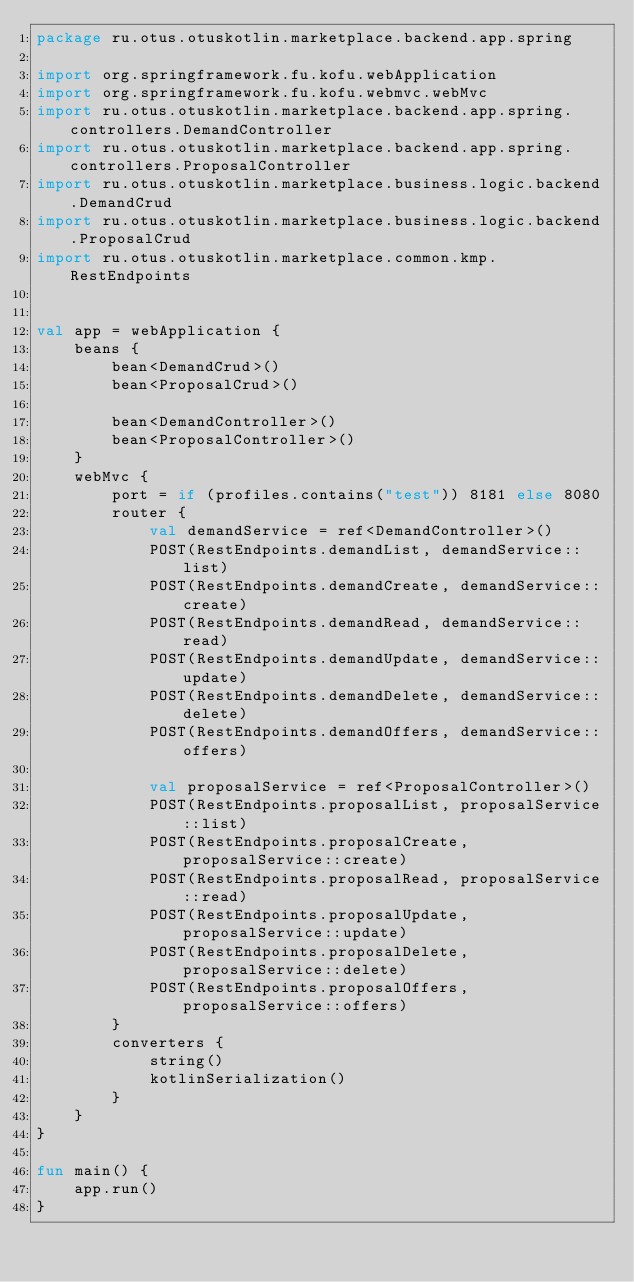<code> <loc_0><loc_0><loc_500><loc_500><_Kotlin_>package ru.otus.otuskotlin.marketplace.backend.app.spring

import org.springframework.fu.kofu.webApplication
import org.springframework.fu.kofu.webmvc.webMvc
import ru.otus.otuskotlin.marketplace.backend.app.spring.controllers.DemandController
import ru.otus.otuskotlin.marketplace.backend.app.spring.controllers.ProposalController
import ru.otus.otuskotlin.marketplace.business.logic.backend.DemandCrud
import ru.otus.otuskotlin.marketplace.business.logic.backend.ProposalCrud
import ru.otus.otuskotlin.marketplace.common.kmp.RestEndpoints


val app = webApplication {
    beans {
        bean<DemandCrud>()
        bean<ProposalCrud>()

        bean<DemandController>()
        bean<ProposalController>()
    }
    webMvc {
        port = if (profiles.contains("test")) 8181 else 8080
        router {
            val demandService = ref<DemandController>()
            POST(RestEndpoints.demandList, demandService::list)
            POST(RestEndpoints.demandCreate, demandService::create)
            POST(RestEndpoints.demandRead, demandService::read)
            POST(RestEndpoints.demandUpdate, demandService::update)
            POST(RestEndpoints.demandDelete, demandService::delete)
            POST(RestEndpoints.demandOffers, demandService::offers)

            val proposalService = ref<ProposalController>()
            POST(RestEndpoints.proposalList, proposalService::list)
            POST(RestEndpoints.proposalCreate, proposalService::create)
            POST(RestEndpoints.proposalRead, proposalService::read)
            POST(RestEndpoints.proposalUpdate, proposalService::update)
            POST(RestEndpoints.proposalDelete, proposalService::delete)
            POST(RestEndpoints.proposalOffers, proposalService::offers)
        }
        converters {
            string()
            kotlinSerialization()
        }
    }
}

fun main() {
    app.run()
}
</code> 